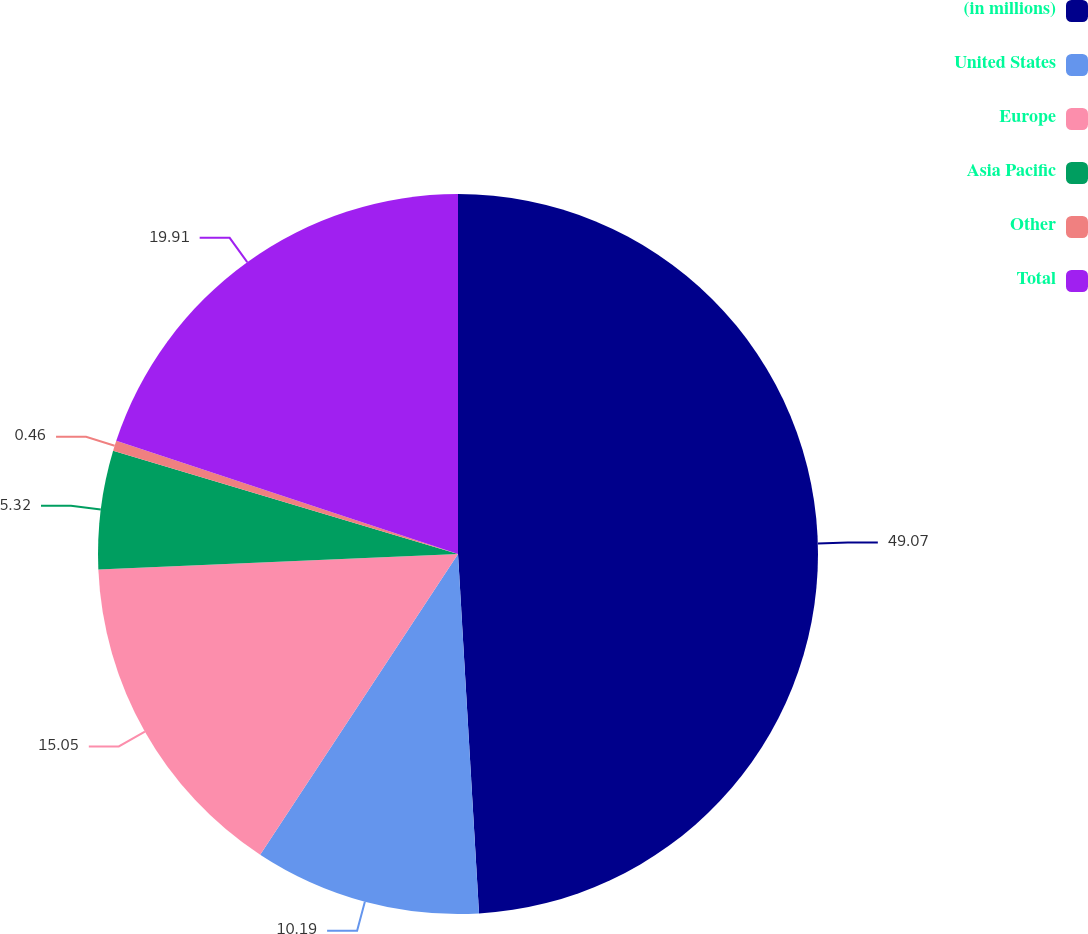Convert chart to OTSL. <chart><loc_0><loc_0><loc_500><loc_500><pie_chart><fcel>(in millions)<fcel>United States<fcel>Europe<fcel>Asia Pacific<fcel>Other<fcel>Total<nl><fcel>49.07%<fcel>10.19%<fcel>15.05%<fcel>5.32%<fcel>0.46%<fcel>19.91%<nl></chart> 